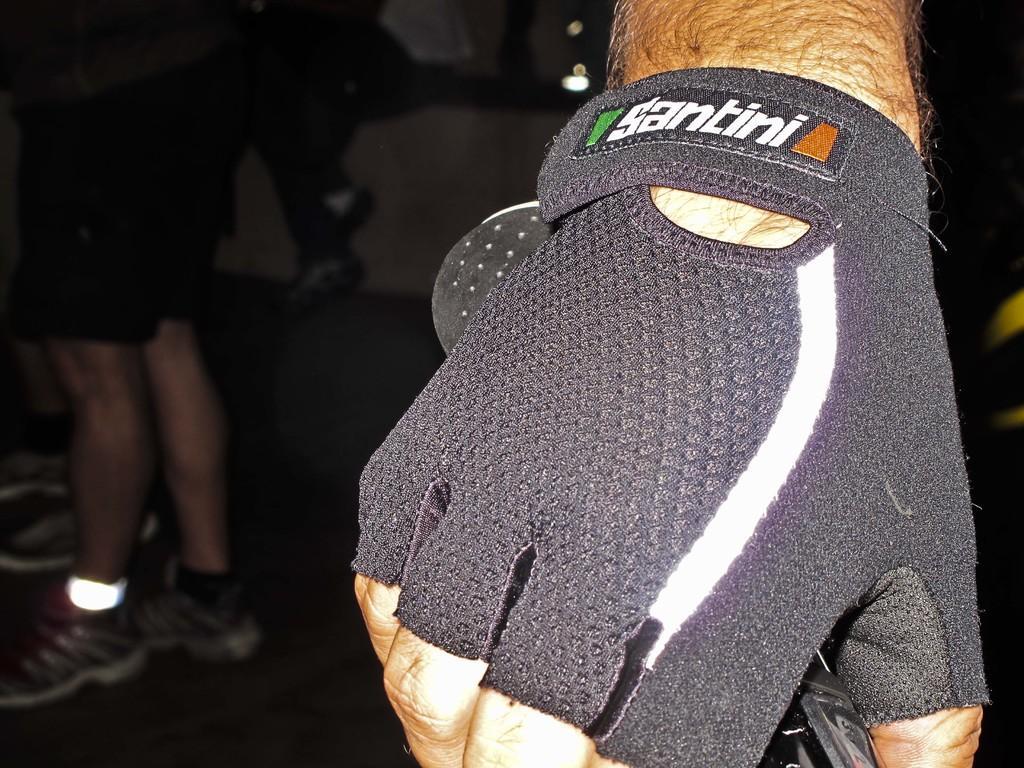Please provide a concise description of this image. In this picture I can see a person´a hand with a glove, holding an object, and in the background there are legs of people. 